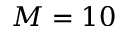<formula> <loc_0><loc_0><loc_500><loc_500>M = 1 0</formula> 